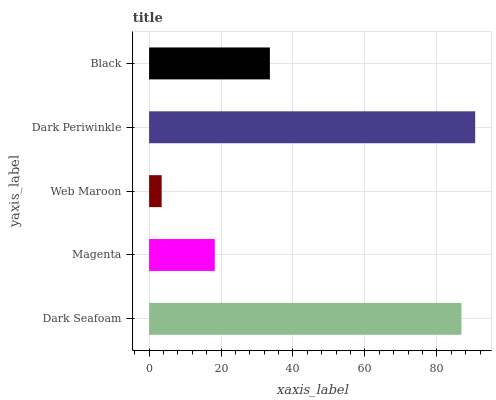Is Web Maroon the minimum?
Answer yes or no. Yes. Is Dark Periwinkle the maximum?
Answer yes or no. Yes. Is Magenta the minimum?
Answer yes or no. No. Is Magenta the maximum?
Answer yes or no. No. Is Dark Seafoam greater than Magenta?
Answer yes or no. Yes. Is Magenta less than Dark Seafoam?
Answer yes or no. Yes. Is Magenta greater than Dark Seafoam?
Answer yes or no. No. Is Dark Seafoam less than Magenta?
Answer yes or no. No. Is Black the high median?
Answer yes or no. Yes. Is Black the low median?
Answer yes or no. Yes. Is Web Maroon the high median?
Answer yes or no. No. Is Magenta the low median?
Answer yes or no. No. 